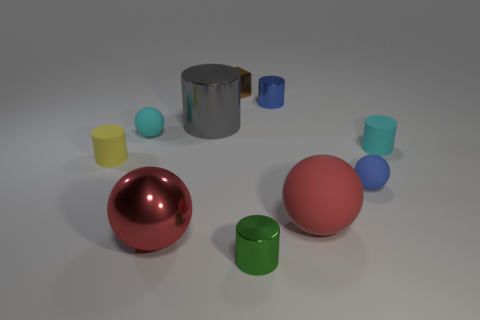Which objects in the image have a reflective surface? The objects with a reflective surface in this image include the large red sphere, the silver cylinder, and the small blue cylinder. 